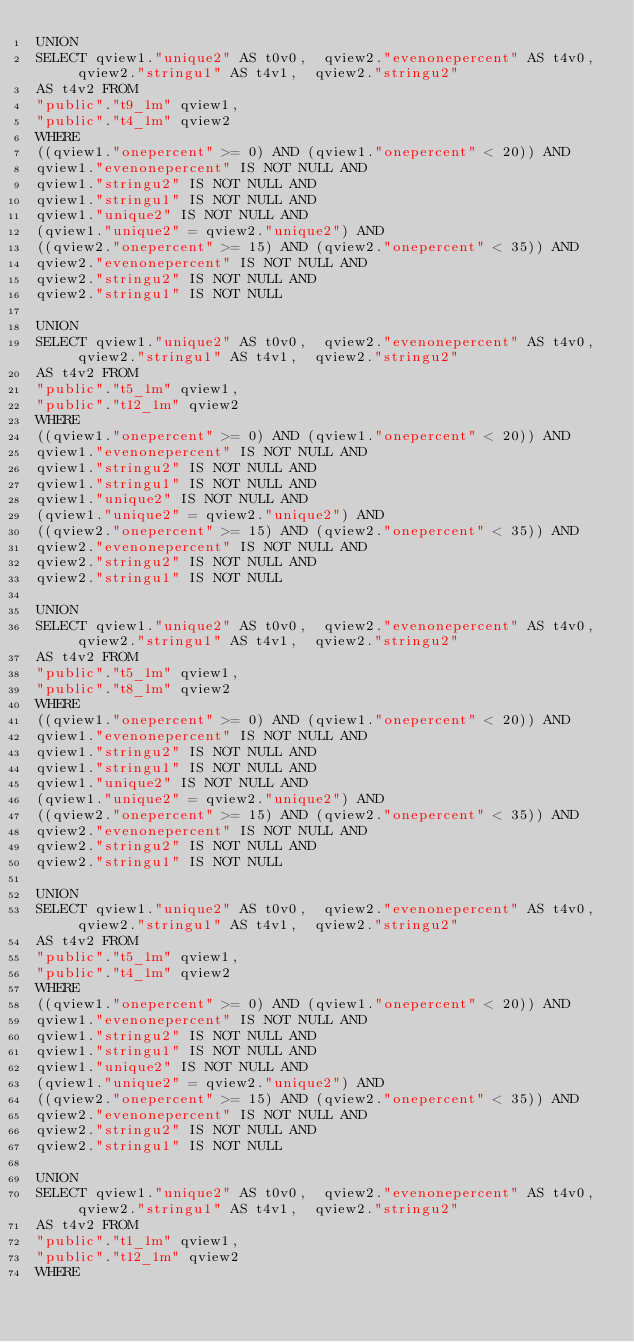<code> <loc_0><loc_0><loc_500><loc_500><_SQL_>UNION
SELECT qview1."unique2" AS t0v0,  qview2."evenonepercent" AS t4v0,  qview2."stringu1" AS t4v1,  qview2."stringu2"
AS t4v2 FROM
"public"."t9_1m" qview1,
"public"."t4_1m" qview2
WHERE
((qview1."onepercent" >= 0) AND (qview1."onepercent" < 20)) AND
qview1."evenonepercent" IS NOT NULL AND
qview1."stringu2" IS NOT NULL AND
qview1."stringu1" IS NOT NULL AND
qview1."unique2" IS NOT NULL AND
(qview1."unique2" = qview2."unique2") AND
((qview2."onepercent" >= 15) AND (qview2."onepercent" < 35)) AND
qview2."evenonepercent" IS NOT NULL AND
qview2."stringu2" IS NOT NULL AND
qview2."stringu1" IS NOT NULL

UNION
SELECT qview1."unique2" AS t0v0,  qview2."evenonepercent" AS t4v0,  qview2."stringu1" AS t4v1,  qview2."stringu2"
AS t4v2 FROM
"public"."t5_1m" qview1,
"public"."t12_1m" qview2
WHERE
((qview1."onepercent" >= 0) AND (qview1."onepercent" < 20)) AND
qview1."evenonepercent" IS NOT NULL AND
qview1."stringu2" IS NOT NULL AND
qview1."stringu1" IS NOT NULL AND
qview1."unique2" IS NOT NULL AND
(qview1."unique2" = qview2."unique2") AND
((qview2."onepercent" >= 15) AND (qview2."onepercent" < 35)) AND
qview2."evenonepercent" IS NOT NULL AND
qview2."stringu2" IS NOT NULL AND
qview2."stringu1" IS NOT NULL

UNION
SELECT qview1."unique2" AS t0v0,  qview2."evenonepercent" AS t4v0,  qview2."stringu1" AS t4v1,  qview2."stringu2"
AS t4v2 FROM
"public"."t5_1m" qview1,
"public"."t8_1m" qview2
WHERE
((qview1."onepercent" >= 0) AND (qview1."onepercent" < 20)) AND
qview1."evenonepercent" IS NOT NULL AND
qview1."stringu2" IS NOT NULL AND
qview1."stringu1" IS NOT NULL AND
qview1."unique2" IS NOT NULL AND
(qview1."unique2" = qview2."unique2") AND
((qview2."onepercent" >= 15) AND (qview2."onepercent" < 35)) AND
qview2."evenonepercent" IS NOT NULL AND
qview2."stringu2" IS NOT NULL AND
qview2."stringu1" IS NOT NULL

UNION
SELECT qview1."unique2" AS t0v0,  qview2."evenonepercent" AS t4v0,  qview2."stringu1" AS t4v1,  qview2."stringu2"
AS t4v2 FROM
"public"."t5_1m" qview1,
"public"."t4_1m" qview2
WHERE
((qview1."onepercent" >= 0) AND (qview1."onepercent" < 20)) AND
qview1."evenonepercent" IS NOT NULL AND
qview1."stringu2" IS NOT NULL AND
qview1."stringu1" IS NOT NULL AND
qview1."unique2" IS NOT NULL AND
(qview1."unique2" = qview2."unique2") AND
((qview2."onepercent" >= 15) AND (qview2."onepercent" < 35)) AND
qview2."evenonepercent" IS NOT NULL AND
qview2."stringu2" IS NOT NULL AND
qview2."stringu1" IS NOT NULL

UNION
SELECT qview1."unique2" AS t0v0,  qview2."evenonepercent" AS t4v0,  qview2."stringu1" AS t4v1,  qview2."stringu2"
AS t4v2 FROM
"public"."t1_1m" qview1,
"public"."t12_1m" qview2
WHERE</code> 